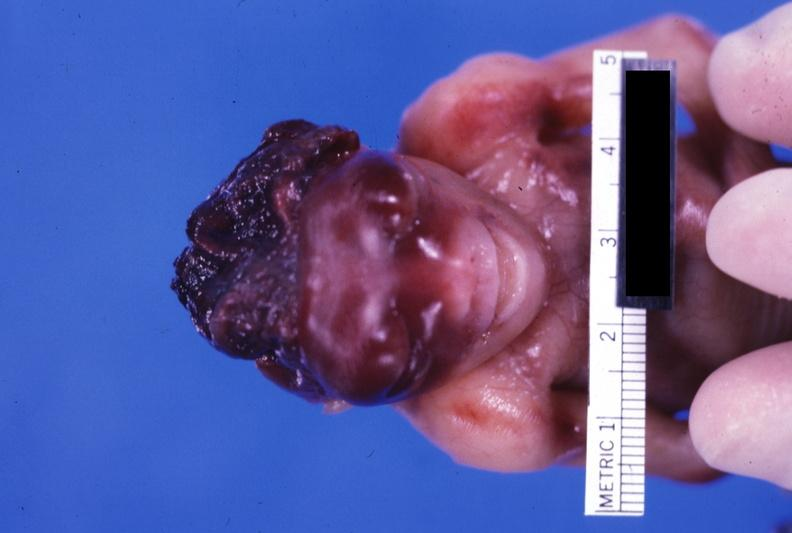does this image show grotesque?
Answer the question using a single word or phrase. Yes 